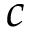<formula> <loc_0><loc_0><loc_500><loc_500>c</formula> 